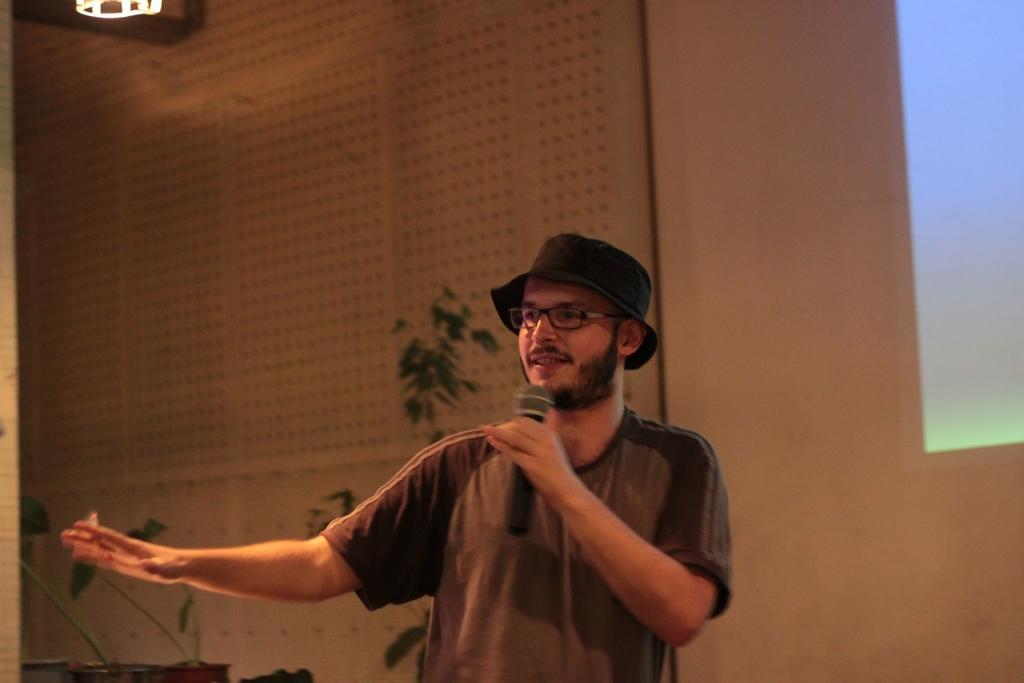How would you summarize this image in a sentence or two? In the foreground of this image, there is a man standing and holding a mic. Behind him, there are few plants, wall and it seems like a screen on the right and an object at the top. 